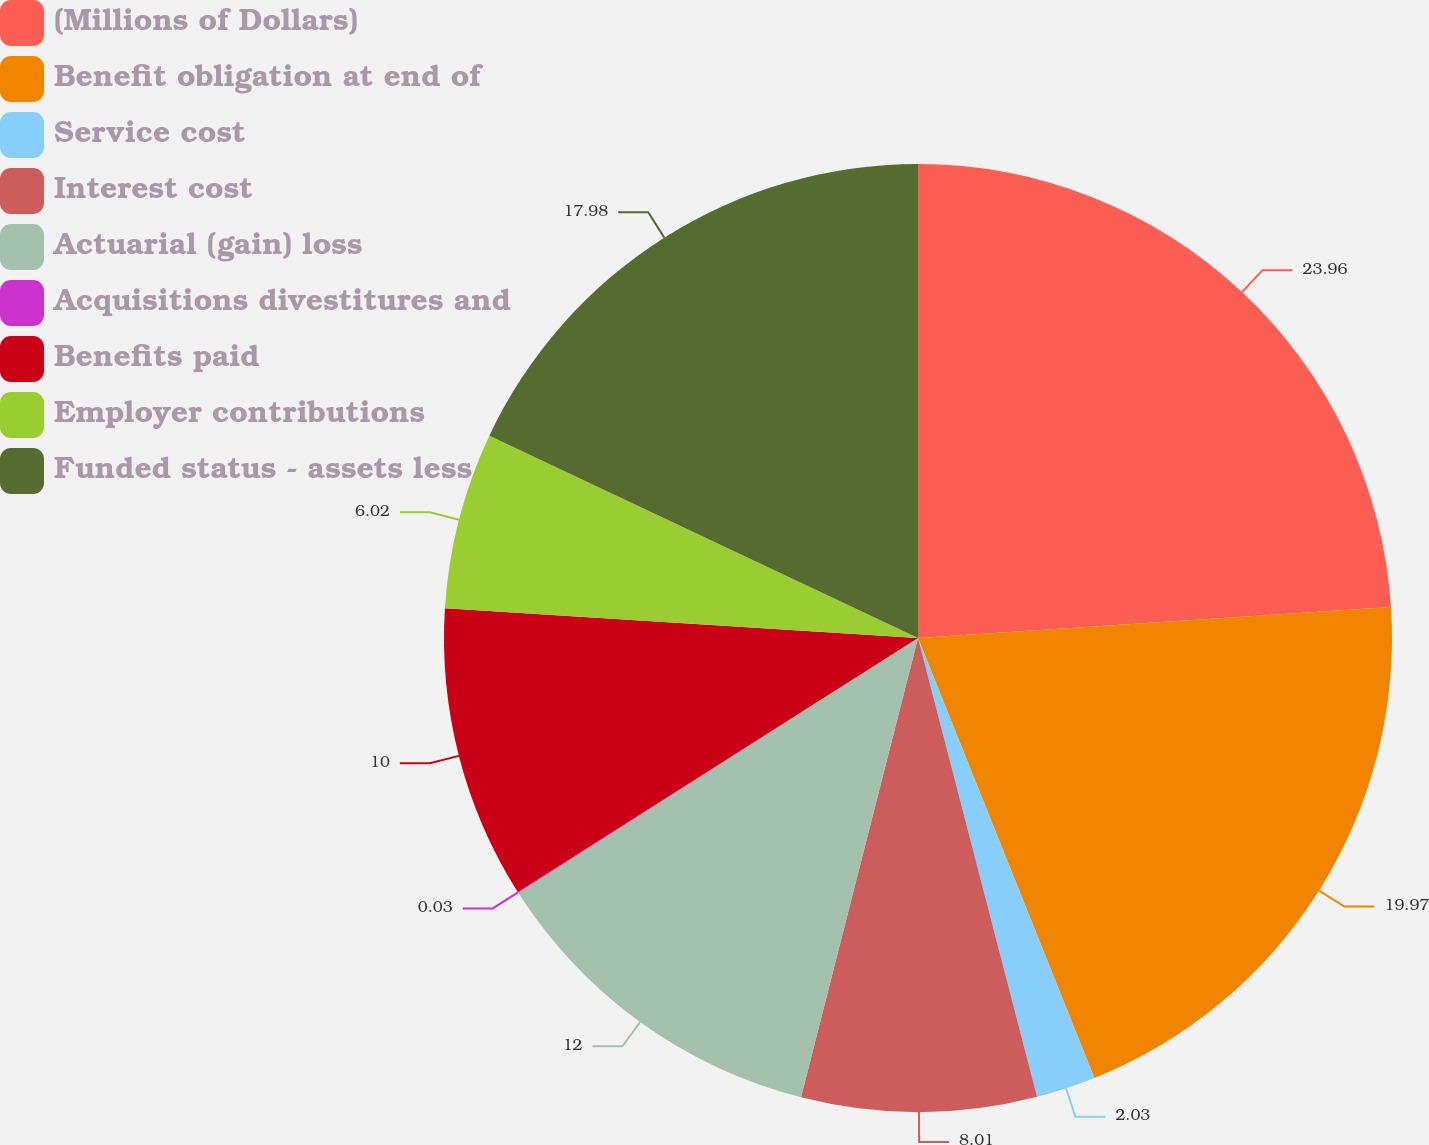<chart> <loc_0><loc_0><loc_500><loc_500><pie_chart><fcel>(Millions of Dollars)<fcel>Benefit obligation at end of<fcel>Service cost<fcel>Interest cost<fcel>Actuarial (gain) loss<fcel>Acquisitions divestitures and<fcel>Benefits paid<fcel>Employer contributions<fcel>Funded status - assets less<nl><fcel>23.96%<fcel>19.97%<fcel>2.03%<fcel>8.01%<fcel>12.0%<fcel>0.03%<fcel>10.0%<fcel>6.02%<fcel>17.98%<nl></chart> 